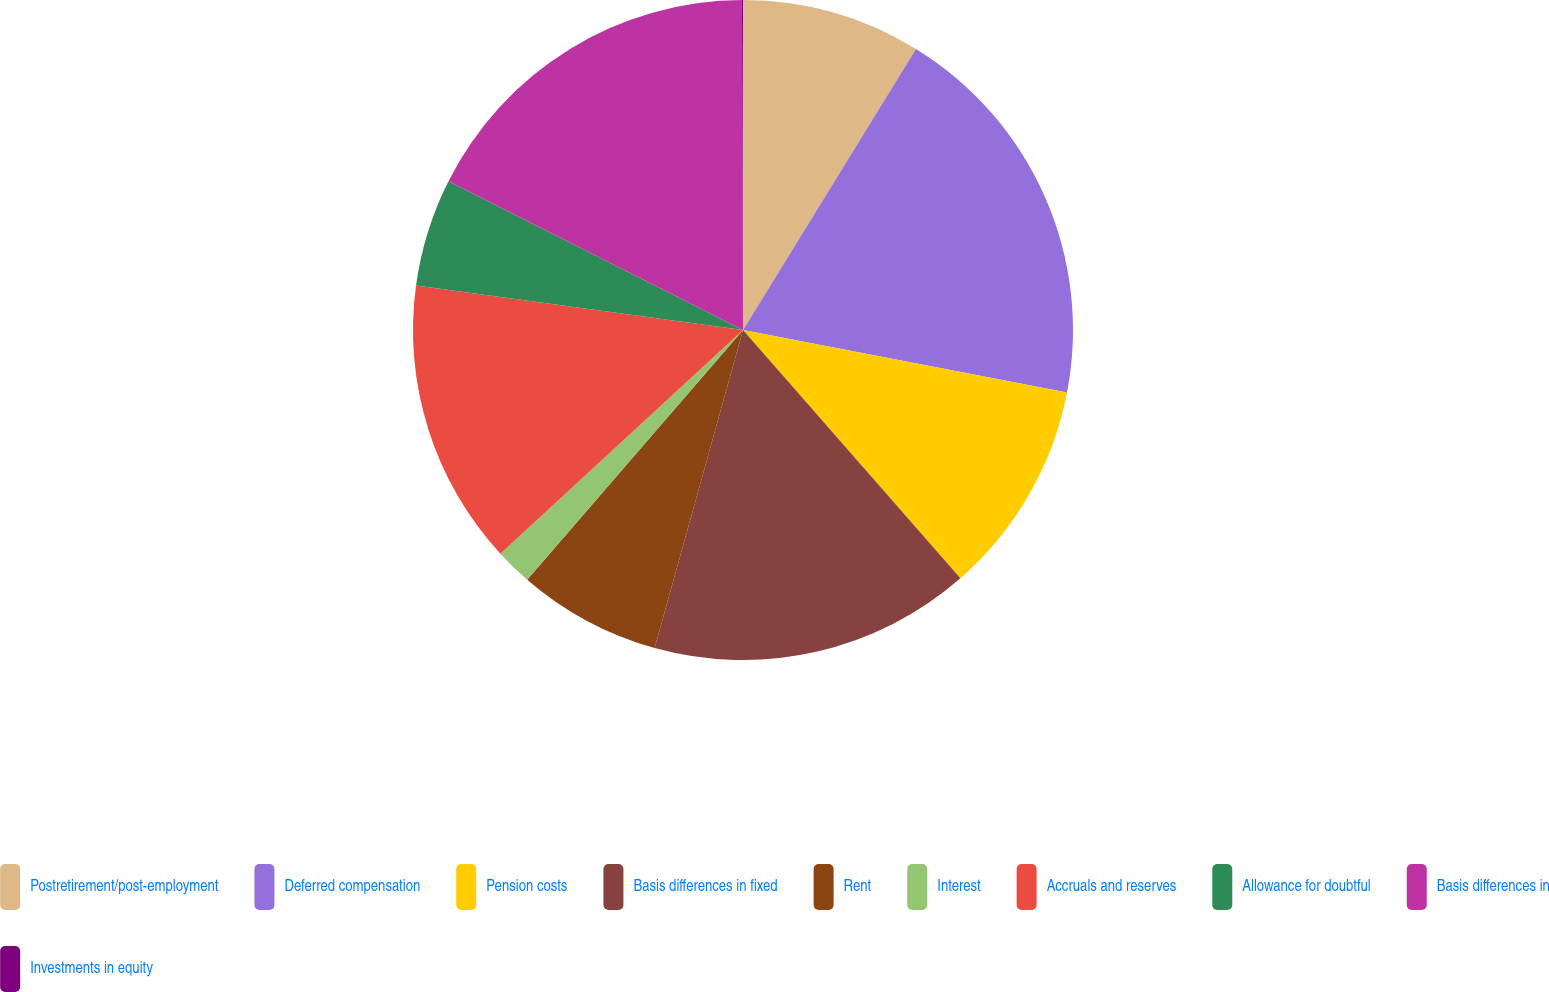<chart> <loc_0><loc_0><loc_500><loc_500><pie_chart><fcel>Postretirement/post-employment<fcel>Deferred compensation<fcel>Pension costs<fcel>Basis differences in fixed<fcel>Rent<fcel>Interest<fcel>Accruals and reserves<fcel>Allowance for doubtful<fcel>Basis differences in<fcel>Investments in equity<nl><fcel>8.78%<fcel>19.25%<fcel>10.52%<fcel>15.76%<fcel>7.03%<fcel>1.8%<fcel>14.01%<fcel>5.29%<fcel>17.5%<fcel>0.05%<nl></chart> 